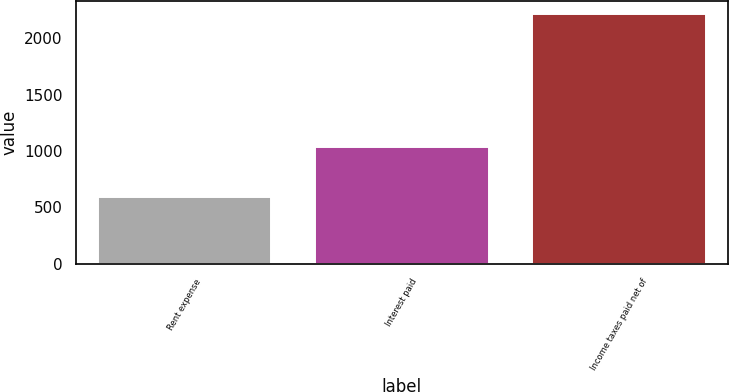Convert chart. <chart><loc_0><loc_0><loc_500><loc_500><bar_chart><fcel>Rent expense<fcel>Interest paid<fcel>Income taxes paid net of<nl><fcel>589<fcel>1039<fcel>2218<nl></chart> 